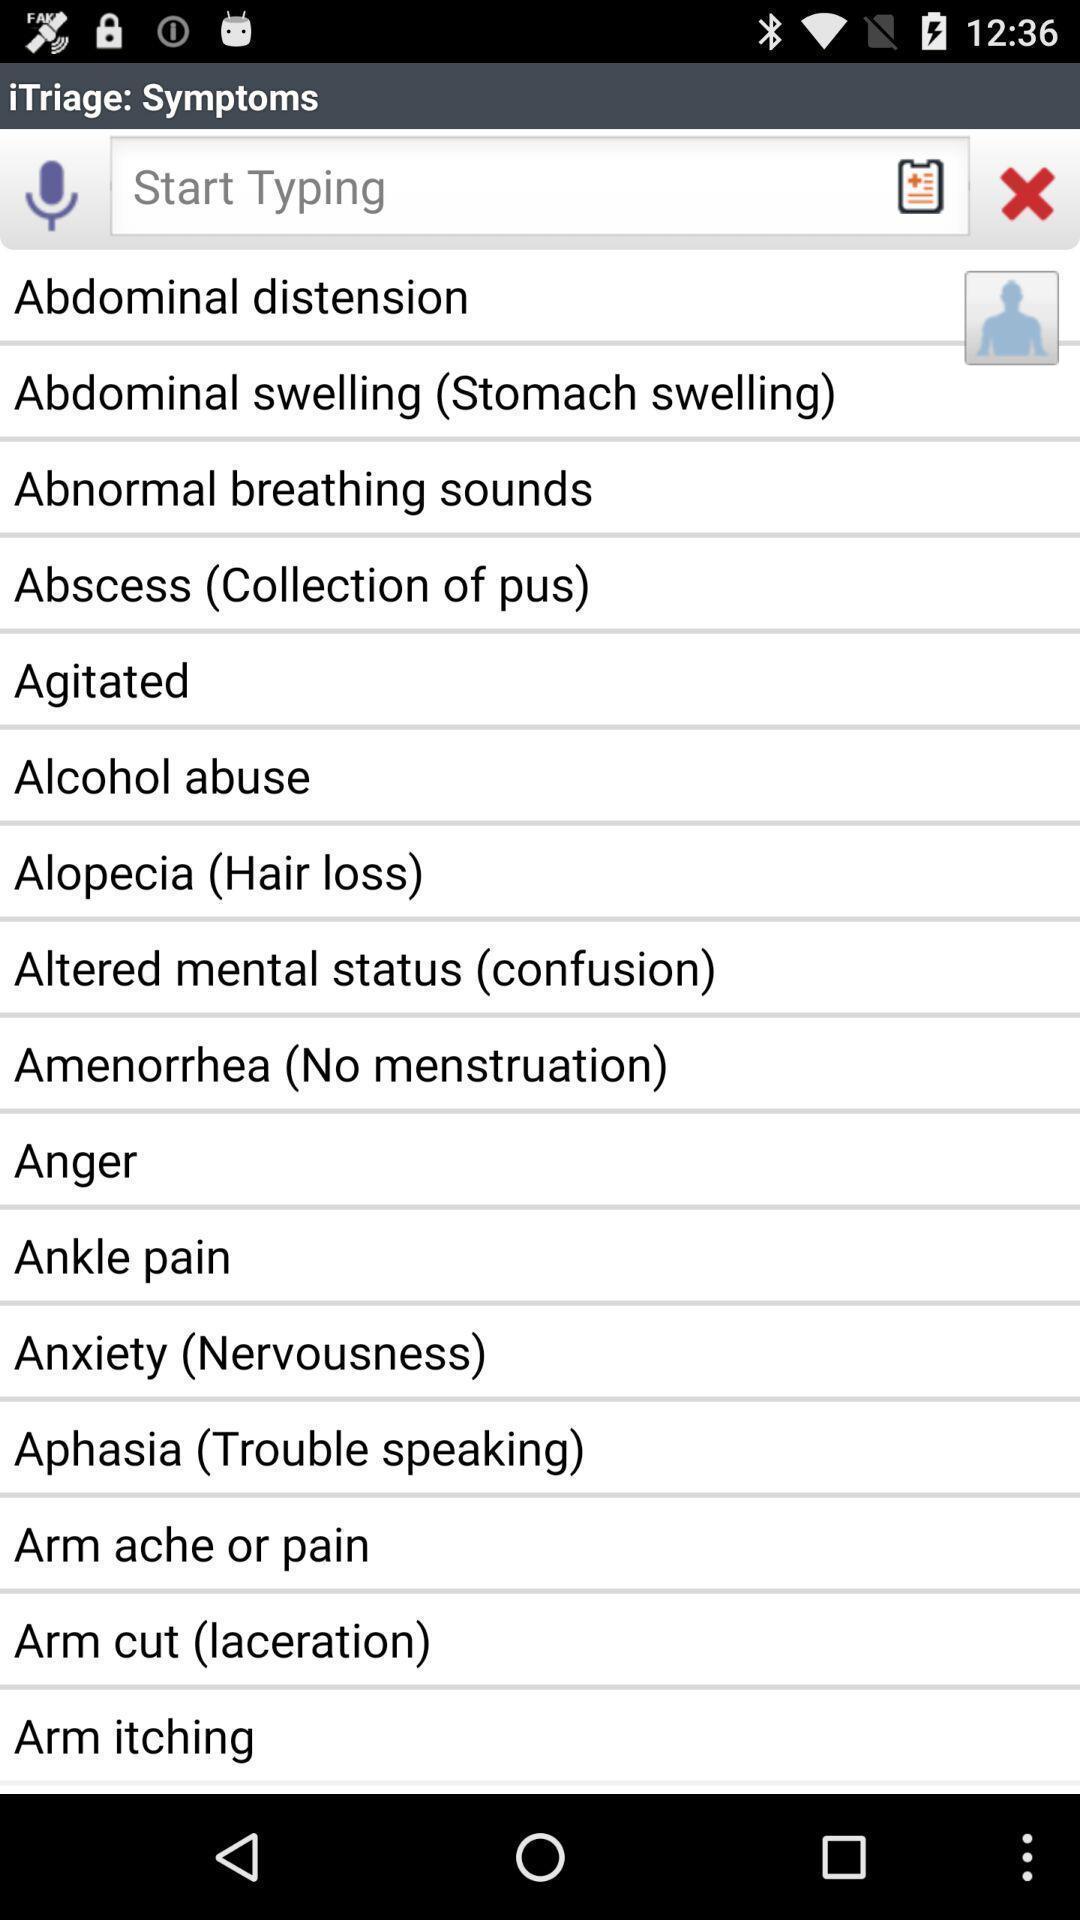Please provide a description for this image. Page displays various health issues in app. 